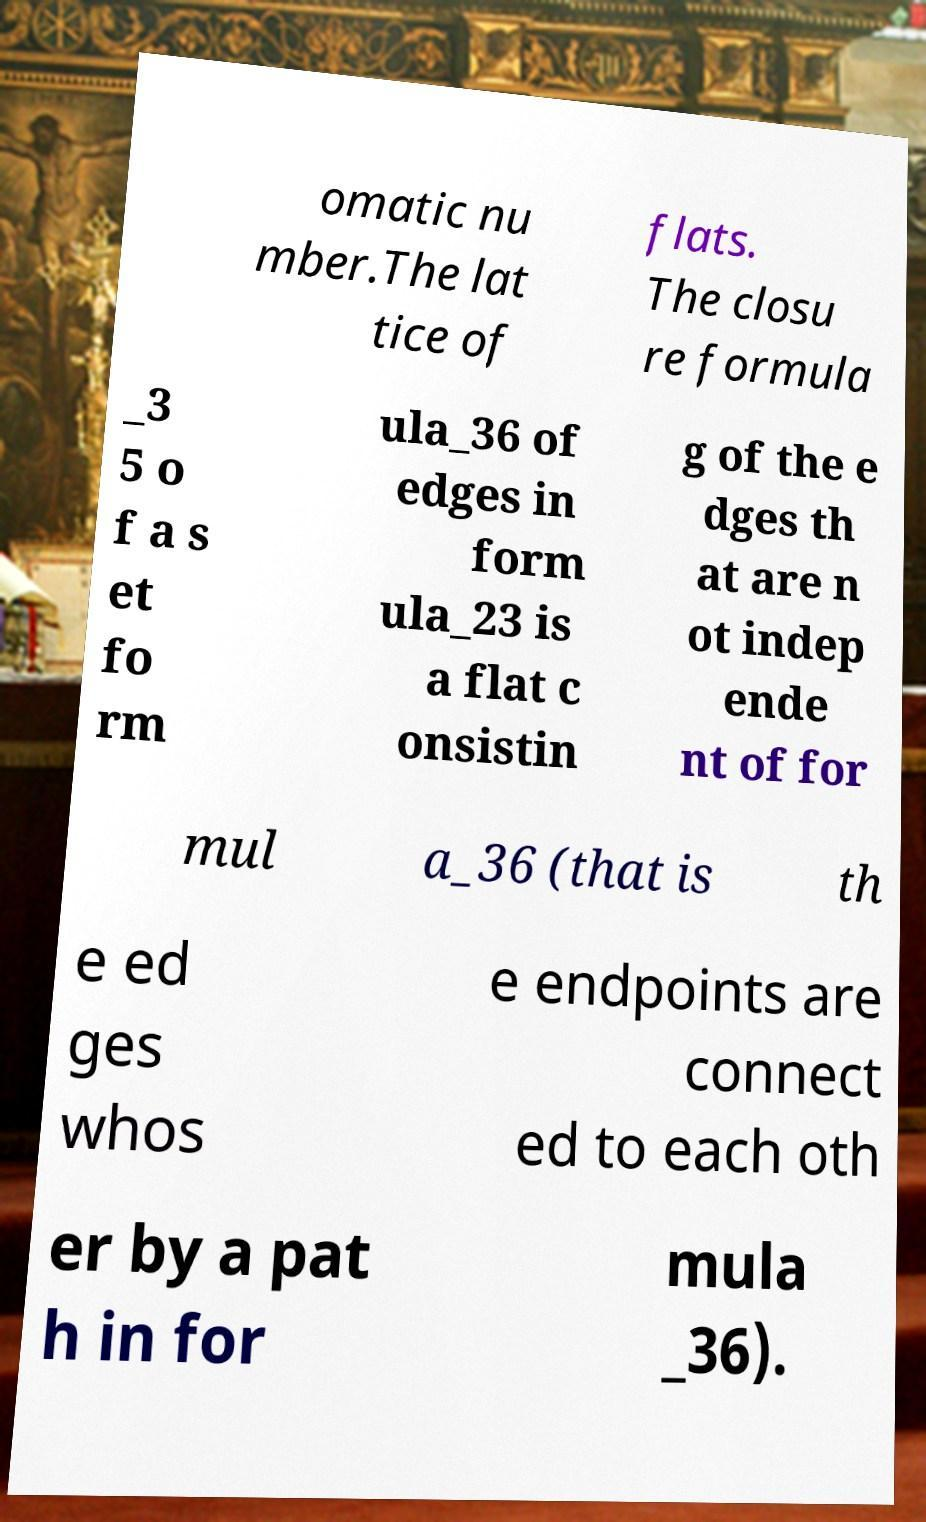For documentation purposes, I need the text within this image transcribed. Could you provide that? omatic nu mber.The lat tice of flats. The closu re formula _3 5 o f a s et fo rm ula_36 of edges in form ula_23 is a flat c onsistin g of the e dges th at are n ot indep ende nt of for mul a_36 (that is th e ed ges whos e endpoints are connect ed to each oth er by a pat h in for mula _36). 